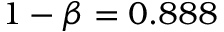<formula> <loc_0><loc_0><loc_500><loc_500>1 - \beta = 0 . 8 8 8</formula> 